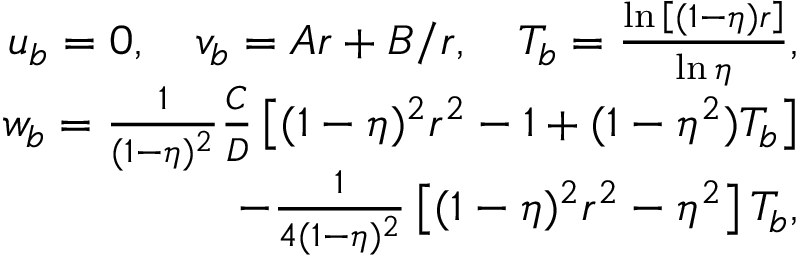Convert formula to latex. <formula><loc_0><loc_0><loc_500><loc_500>\begin{array} { r } { u _ { b } = 0 , \quad v _ { b } = A r + B / r , \quad T _ { b } = \frac { \ln { \left [ ( 1 - \eta ) r \right ] } } { \ln { \eta } } , } \\ { w _ { b } = \frac { 1 } { ( 1 - \eta ) ^ { 2 } } \frac { C } { D } \left [ ( 1 - \eta ) ^ { 2 } r ^ { 2 } - 1 + ( 1 - \eta ^ { 2 } ) T _ { b } \right ] } \\ { - \frac { 1 } { 4 ( 1 - \eta ) ^ { 2 } } \left [ ( 1 - \eta ) ^ { 2 } r ^ { 2 } - \eta ^ { 2 } \right ] T _ { b } , } \end{array}</formula> 